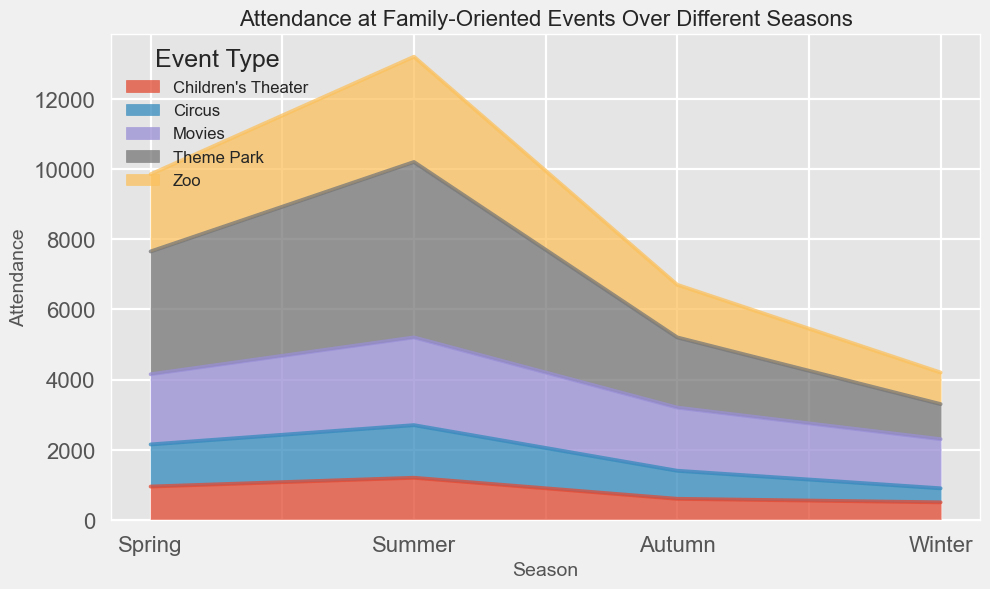Which season has the highest attendance at family-oriented events overall? Looking at the area chart, compare the total area (sum of all event types) for each season. Summer shows the largest total area, indicating the highest attendance.
Answer: Summer How does the attendance at the circus in winter compare to the attendance in autumn? Inspect the height of the area representing the circus for both winter and autumn. The height for winter (400) is less than autumn (800).
Answer: Less in winter Which single event type has the highest attendance during summer? Check the specific event areas for summer. Theme Park has the highest attendance with 5000.
Answer: Theme Park What is the average attendance for children's theater across all seasons? Find the attendance for each season for children's theater: Spring (950), Summer (1200), Autumn (600), Winter (500). Calculate the average: (950 + 1200 + 600 + 500) / 4 = 812.5
Answer: 812.5 Is the attendance for movies greater in winter or spring? Look at the height of the movie area for winter (1400) and spring (2000). The attendance in spring is higher.
Answer: Spring What's the total attendance for zoo events through all seasons? Sum the attendance for zoo events: Spring (2200), Summer (3000), Autumn (1500), Winter (900). Calculate: 2200 + 3000 + 1500 + 900 = 7600.
Answer: 7600 How does the attendance for theme parks change from spring to summer? Compare the height of the theme park area in spring (3500) and summer (5000). It increases.
Answer: Increases Which season has the lowest attendance for all event types combined? Identify the season with the smallest total area (sum of all event types). Winter has the smallest area.
Answer: Winter During which season is there the smallest difference in attendance between the zoo and movies? Check the height difference between zoo and movies for each season. For simplification: 
- Spring: 2200 (Zoo) - 2000 (Movies) = 200
- Summer: 3000 (Zoo) - 2500 (Movies) = 500
- Autumn: 1500 (Zoo) - 1800 (Movies) = 300
- Winter: 900 (Zoo) - 1400 (Movies) = 500
The difference is smallest in Spring (200).
Answer: Spring What's the total attendance across all event types in autumn? Sum all attendance values for autumn: Circus (800), Theme Park (2000), Zoo (1500), Children's Theater (600), Movies (1800). Calculate: 800 + 2000 + 1500 + 600 + 1800 = 6700.
Answer: 6700 